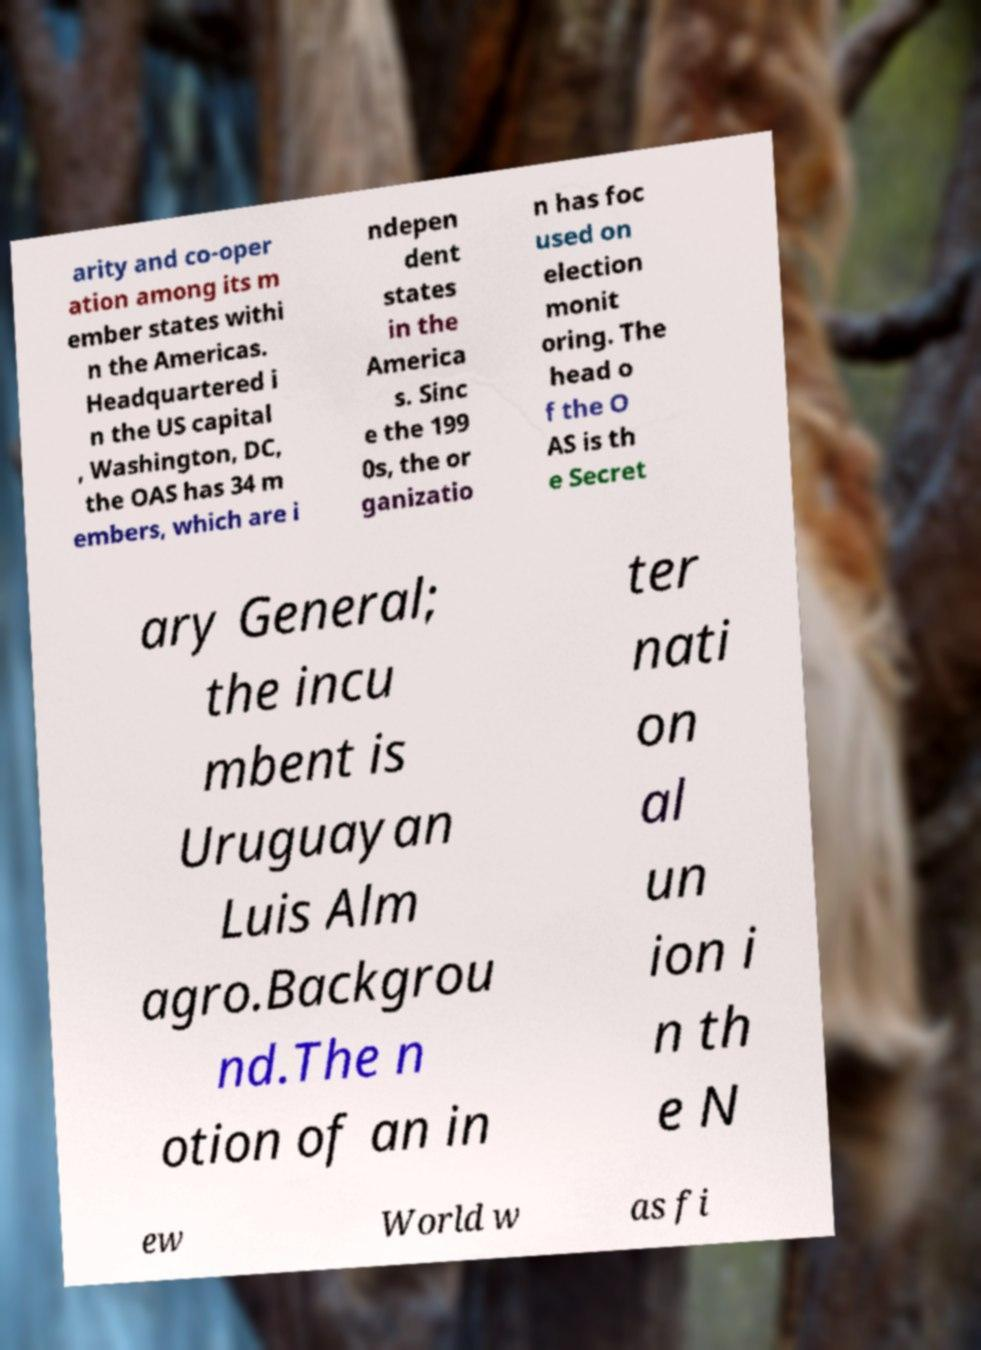Please read and relay the text visible in this image. What does it say? arity and co-oper ation among its m ember states withi n the Americas. Headquartered i n the US capital , Washington, DC, the OAS has 34 m embers, which are i ndepen dent states in the America s. Sinc e the 199 0s, the or ganizatio n has foc used on election monit oring. The head o f the O AS is th e Secret ary General; the incu mbent is Uruguayan Luis Alm agro.Backgrou nd.The n otion of an in ter nati on al un ion i n th e N ew World w as fi 